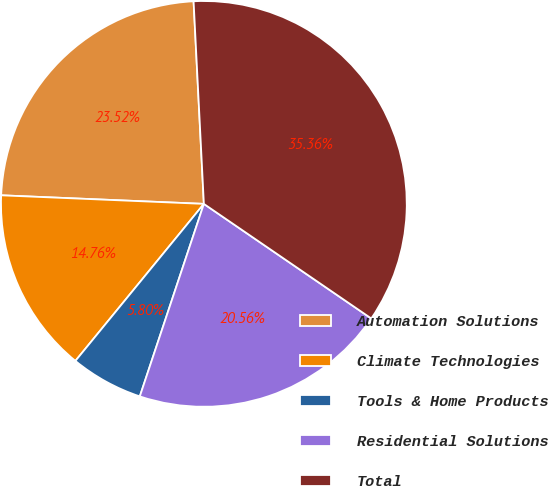Convert chart to OTSL. <chart><loc_0><loc_0><loc_500><loc_500><pie_chart><fcel>Automation Solutions<fcel>Climate Technologies<fcel>Tools & Home Products<fcel>Residential Solutions<fcel>Total<nl><fcel>23.52%<fcel>14.76%<fcel>5.8%<fcel>20.56%<fcel>35.36%<nl></chart> 